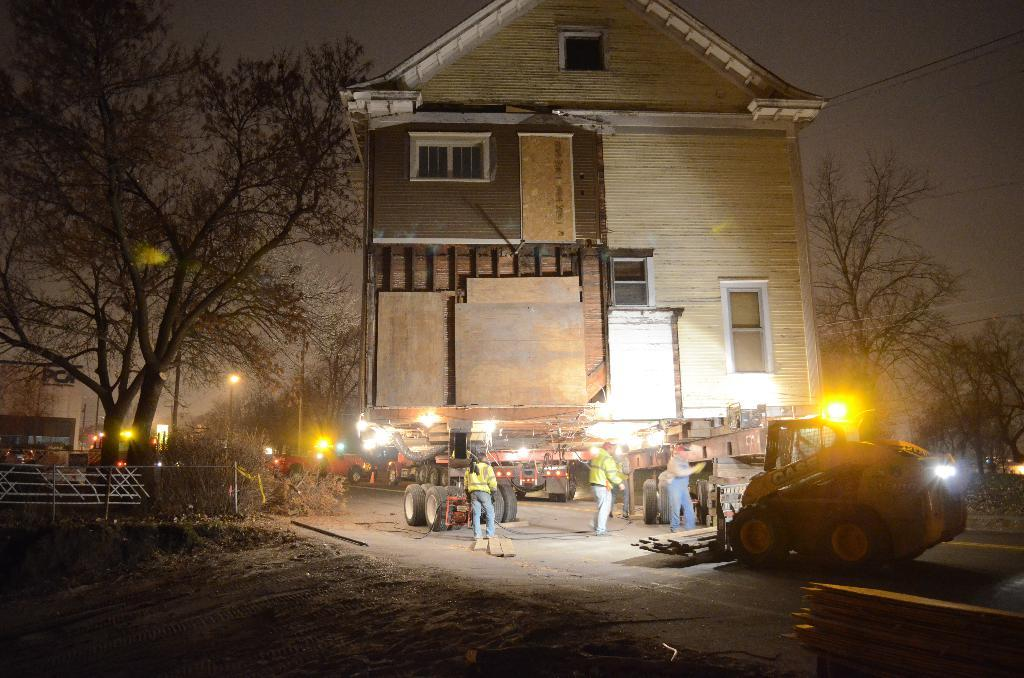How many people are present in the image? There is a group of people standing in the image, but the exact number cannot be determined from the provided facts. What can be seen on the road in the image? There are vehicles on the road in the image. What type of structure is visible in the image? There is a house in the image. What objects are present in the image that emit light? There are lights in the image. What type of vertical structures can be seen in the image? There are poles in the image. What type of vegetation is visible in the image? There are trees in the image. What part of the natural environment is visible in the image? The sky is visible in the image. Where is the mailbox located in the image? There is no mention of a mailbox in the provided facts, so its location cannot be determined. What type of attack is happening in the image? There is no indication of an attack in the image; it features a group of people, vehicles, a house, lights, poles, trees, and the sky. What type of toothpaste is being used by the people in the image? There is no mention of toothpaste in the provided facts, so it cannot be determined if it is being used by anyone in the image. 